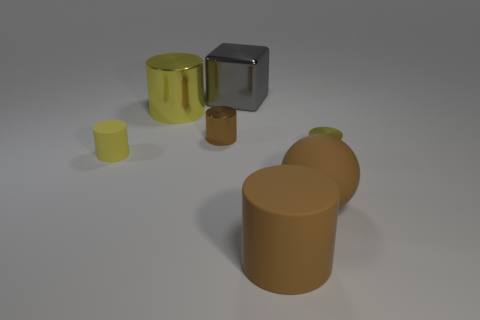Subtract all yellow cylinders. How many were subtracted if there are1yellow cylinders left? 2 Add 3 small rubber spheres. How many objects exist? 10 Subtract all tiny yellow rubber cylinders. How many cylinders are left? 4 Subtract all brown metal cylinders. Subtract all big spheres. How many objects are left? 5 Add 7 small metal cylinders. How many small metal cylinders are left? 9 Add 1 large things. How many large things exist? 5 Subtract all yellow cylinders. How many cylinders are left? 2 Subtract 0 blue blocks. How many objects are left? 7 Subtract all spheres. How many objects are left? 6 Subtract 4 cylinders. How many cylinders are left? 1 